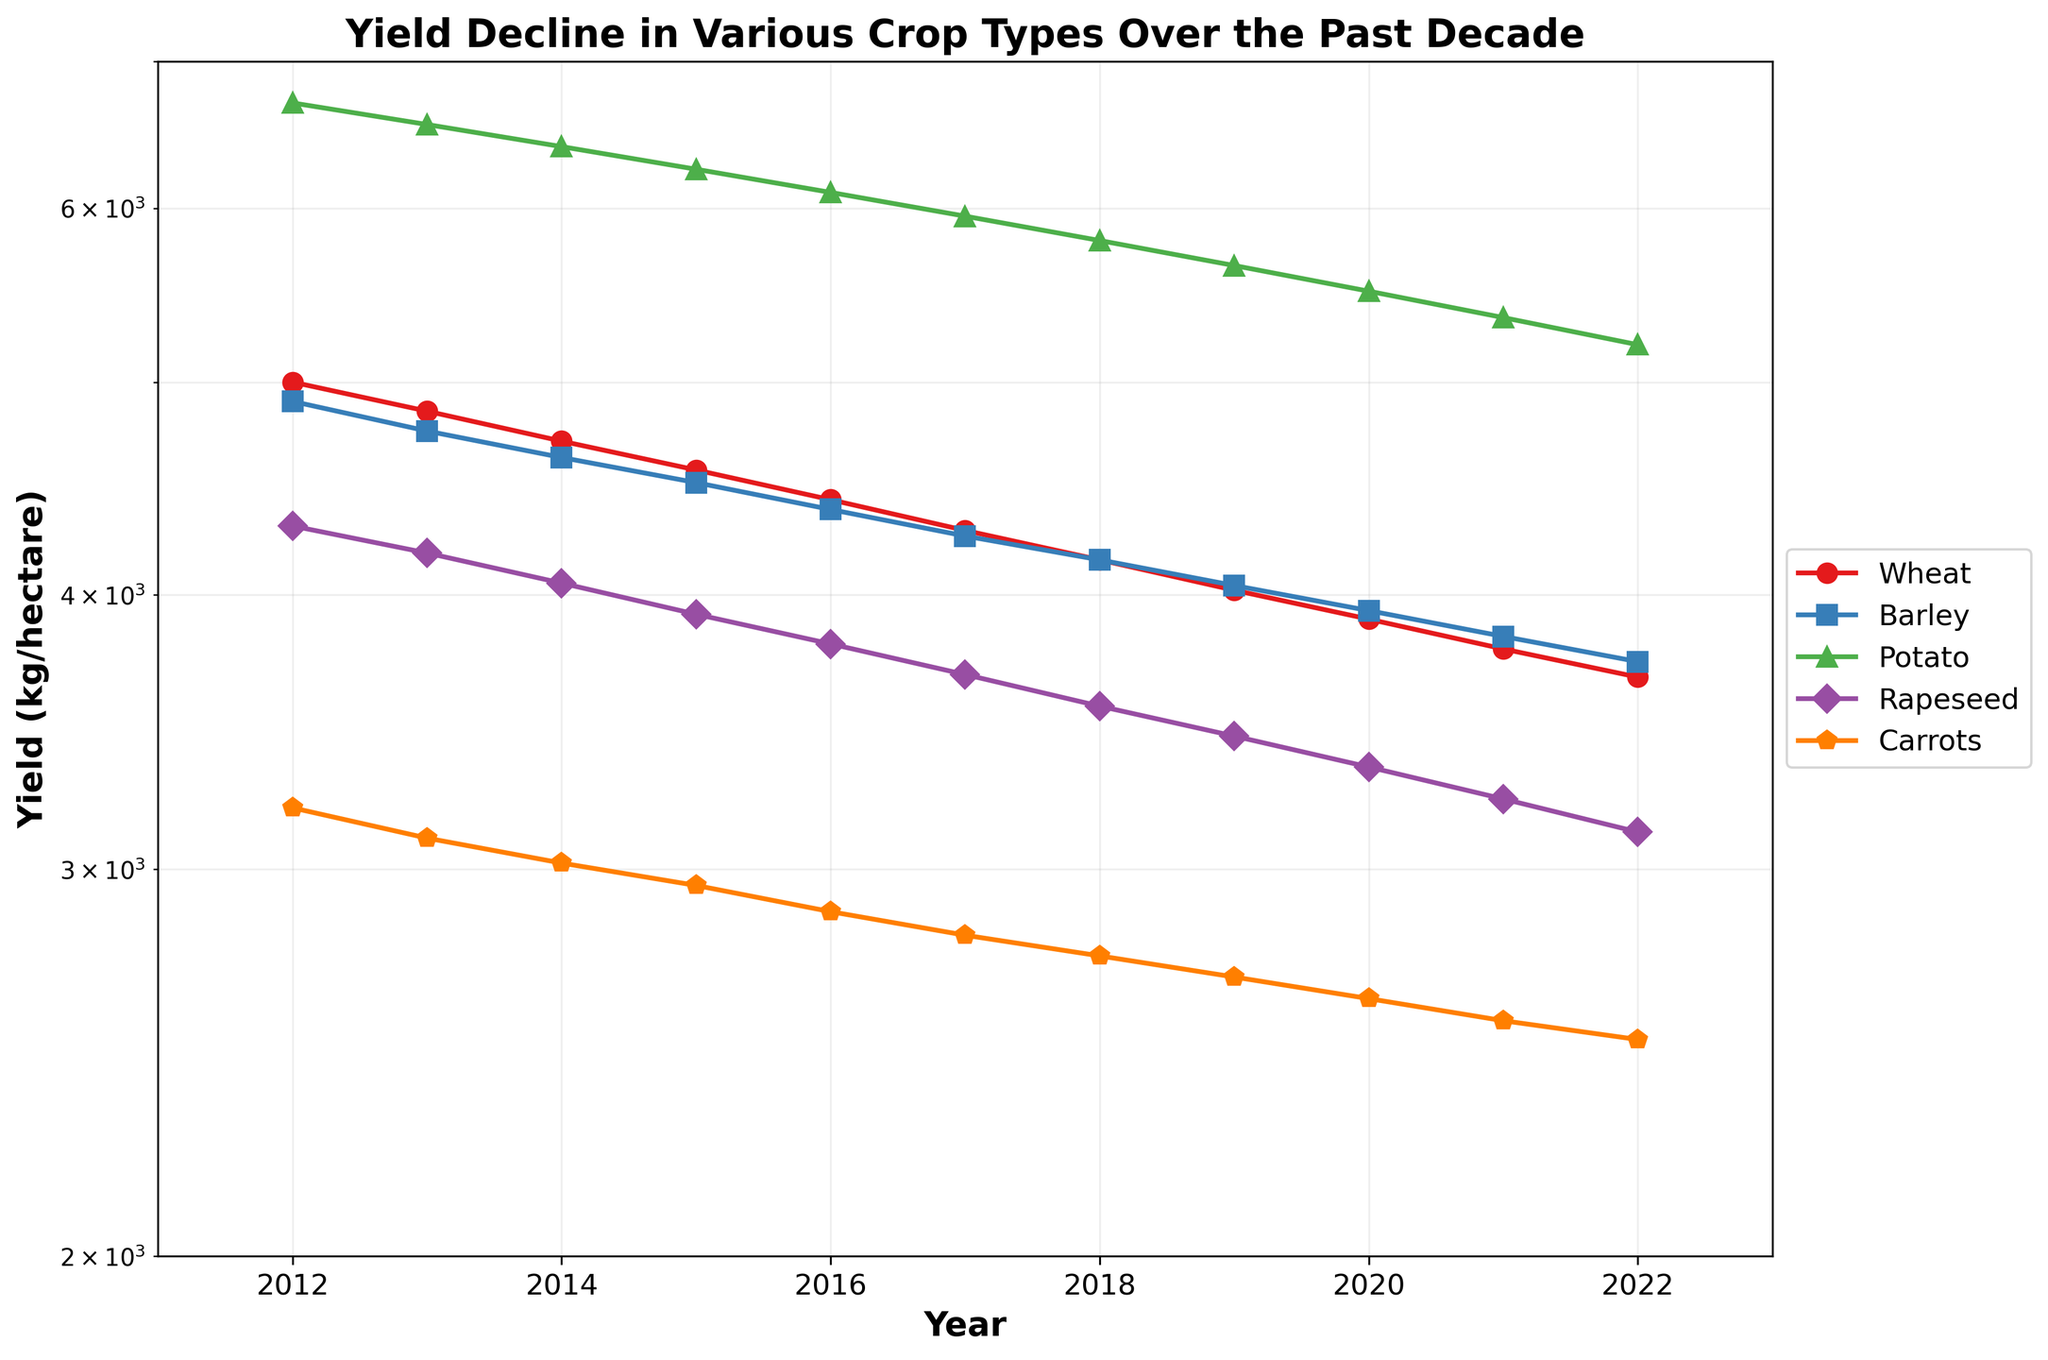What is the title of the figure? The title of the figure is usually located at the top of the plot. From the given information, the title is "Yield Decline in Various Crop Types Over the Past Decade".
Answer: Yield Decline in Various Crop Types Over the Past Decade What is the scale type of the y-axis? The scale type can usually be inferred from the axis label or notation. In this figure, the y-axis uses a logarithmic (log) scale.
Answer: Logarithmic Which crop had the highest yield in 2012? By looking at the starting points of the lines in 2012, we identify the highest position. Potato had the highest yield in that year.
Answer: Potato How has the yield of Barley changed from 2012 to 2022? We compare the Barley yield at the start (4900 kg/hectare in 2012) and end points (3730 kg/hectare in 2022) on the plot. The yield has decreased over this period.
Answer: Decreased What is the range of the y-axis? The y-axis range can be read from the top and bottom limits on the plot. It's between 2000 and 7000 kg/hectare.
Answer: 2000 to 7000 kg/hectare Which crop had a yield closest to 3000 kg/hectare around 2017? By inspecting the y-axis values around the year 2017, Carrots are the closest to 3000 kg/hectare.
Answer: Carrots Calculate the average yield of Rapeseed for the years 2012 and 2022. First identify the yields for Rapeseed in 2012 (4300 kg/hectare) and 2022 (3120 kg/hectare). The average is (4300 + 3120) / 2.
Answer: 3710 kg/hectare Which crop had the smallest decline in yield over the decade? By comparing the changes in yield from 2012 to 2022 for all crops, Barley had a smaller decline (4900 to 3730 kg/hectare) compared to others.
Answer: Barley In which year did Carrots yield fall below 3000 kg/hectare for the first time? By following the line for Carrots and checking where it first dips below the 3000 mark, it's in 2016.
Answer: 2016 